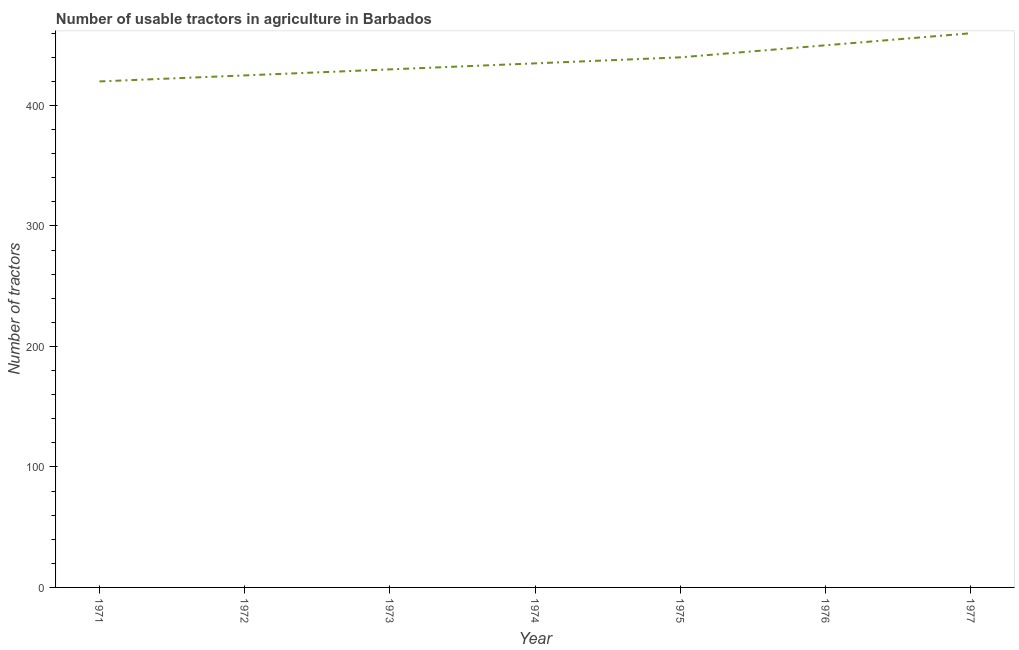What is the number of tractors in 1971?
Make the answer very short. 420. Across all years, what is the maximum number of tractors?
Provide a succinct answer. 460. Across all years, what is the minimum number of tractors?
Make the answer very short. 420. In which year was the number of tractors maximum?
Give a very brief answer. 1977. In which year was the number of tractors minimum?
Offer a very short reply. 1971. What is the sum of the number of tractors?
Offer a terse response. 3060. What is the difference between the number of tractors in 1974 and 1977?
Make the answer very short. -25. What is the average number of tractors per year?
Ensure brevity in your answer.  437.14. What is the median number of tractors?
Ensure brevity in your answer.  435. In how many years, is the number of tractors greater than 200 ?
Your answer should be very brief. 7. Do a majority of the years between 1975 and 1973 (inclusive) have number of tractors greater than 240 ?
Your answer should be very brief. No. What is the ratio of the number of tractors in 1973 to that in 1976?
Keep it short and to the point. 0.96. Is the sum of the number of tractors in 1972 and 1973 greater than the maximum number of tractors across all years?
Give a very brief answer. Yes. What is the difference between the highest and the lowest number of tractors?
Your response must be concise. 40. In how many years, is the number of tractors greater than the average number of tractors taken over all years?
Provide a short and direct response. 3. How many lines are there?
Your answer should be very brief. 1. What is the difference between two consecutive major ticks on the Y-axis?
Your answer should be compact. 100. What is the title of the graph?
Your answer should be very brief. Number of usable tractors in agriculture in Barbados. What is the label or title of the Y-axis?
Give a very brief answer. Number of tractors. What is the Number of tractors of 1971?
Provide a succinct answer. 420. What is the Number of tractors in 1972?
Ensure brevity in your answer.  425. What is the Number of tractors in 1973?
Provide a short and direct response. 430. What is the Number of tractors in 1974?
Provide a succinct answer. 435. What is the Number of tractors in 1975?
Give a very brief answer. 440. What is the Number of tractors in 1976?
Your response must be concise. 450. What is the Number of tractors in 1977?
Your response must be concise. 460. What is the difference between the Number of tractors in 1971 and 1972?
Your answer should be very brief. -5. What is the difference between the Number of tractors in 1971 and 1975?
Offer a terse response. -20. What is the difference between the Number of tractors in 1971 and 1977?
Your answer should be very brief. -40. What is the difference between the Number of tractors in 1972 and 1975?
Provide a succinct answer. -15. What is the difference between the Number of tractors in 1972 and 1976?
Keep it short and to the point. -25. What is the difference between the Number of tractors in 1972 and 1977?
Your response must be concise. -35. What is the difference between the Number of tractors in 1973 and 1974?
Provide a succinct answer. -5. What is the difference between the Number of tractors in 1973 and 1976?
Provide a succinct answer. -20. What is the difference between the Number of tractors in 1973 and 1977?
Ensure brevity in your answer.  -30. What is the difference between the Number of tractors in 1974 and 1977?
Keep it short and to the point. -25. What is the difference between the Number of tractors in 1975 and 1976?
Your answer should be compact. -10. What is the difference between the Number of tractors in 1975 and 1977?
Provide a succinct answer. -20. What is the difference between the Number of tractors in 1976 and 1977?
Keep it short and to the point. -10. What is the ratio of the Number of tractors in 1971 to that in 1972?
Your answer should be very brief. 0.99. What is the ratio of the Number of tractors in 1971 to that in 1973?
Provide a succinct answer. 0.98. What is the ratio of the Number of tractors in 1971 to that in 1975?
Offer a very short reply. 0.95. What is the ratio of the Number of tractors in 1971 to that in 1976?
Your answer should be very brief. 0.93. What is the ratio of the Number of tractors in 1972 to that in 1973?
Your answer should be very brief. 0.99. What is the ratio of the Number of tractors in 1972 to that in 1976?
Give a very brief answer. 0.94. What is the ratio of the Number of tractors in 1972 to that in 1977?
Your answer should be compact. 0.92. What is the ratio of the Number of tractors in 1973 to that in 1974?
Keep it short and to the point. 0.99. What is the ratio of the Number of tractors in 1973 to that in 1976?
Offer a very short reply. 0.96. What is the ratio of the Number of tractors in 1973 to that in 1977?
Your answer should be very brief. 0.94. What is the ratio of the Number of tractors in 1974 to that in 1976?
Keep it short and to the point. 0.97. What is the ratio of the Number of tractors in 1974 to that in 1977?
Offer a terse response. 0.95. 